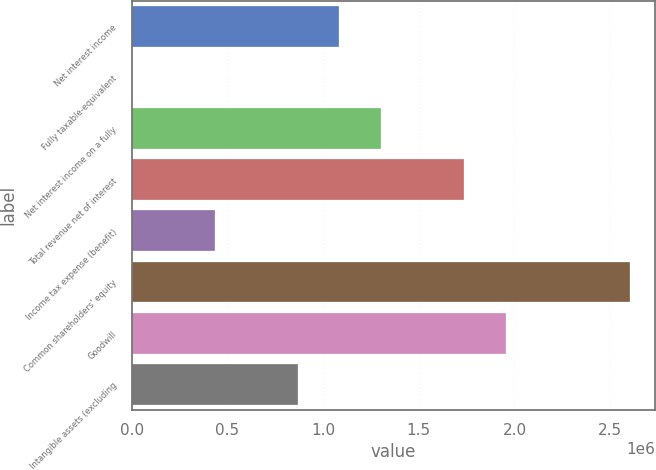Convert chart. <chart><loc_0><loc_0><loc_500><loc_500><bar_chart><fcel>Net interest income<fcel>Fully taxable-equivalent<fcel>Net interest income on a fully<fcel>Total revenue net of interest<fcel>Income tax expense (benefit)<fcel>Common shareholders' equity<fcel>Goodwill<fcel>Intangible assets (excluding<nl><fcel>1.08538e+06<fcel>213<fcel>1.30242e+06<fcel>1.73649e+06<fcel>434282<fcel>2.60463e+06<fcel>1.95352e+06<fcel>868351<nl></chart> 